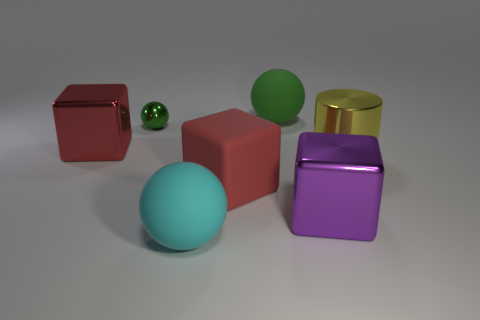Is the number of big green matte things in front of the cyan ball greater than the number of big yellow cylinders?
Make the answer very short. No. What number of yellow shiny cylinders are to the left of the object in front of the metallic cube that is to the right of the tiny shiny ball?
Give a very brief answer. 0. There is a rubber object in front of the big rubber cube; does it have the same shape as the red metallic thing?
Your answer should be very brief. No. There is a large cyan object in front of the small metal sphere; what is its material?
Make the answer very short. Rubber. The large shiny thing that is both behind the big red matte object and on the left side of the cylinder has what shape?
Your answer should be very brief. Cube. What is the large yellow cylinder made of?
Make the answer very short. Metal. How many balls are either small shiny things or green rubber objects?
Your answer should be compact. 2. Does the cyan object have the same material as the tiny green ball?
Offer a very short reply. No. There is a red rubber thing that is the same shape as the purple shiny object; what is its size?
Provide a succinct answer. Large. There is a big cube that is both on the right side of the green metallic sphere and on the left side of the purple cube; what material is it?
Give a very brief answer. Rubber. 